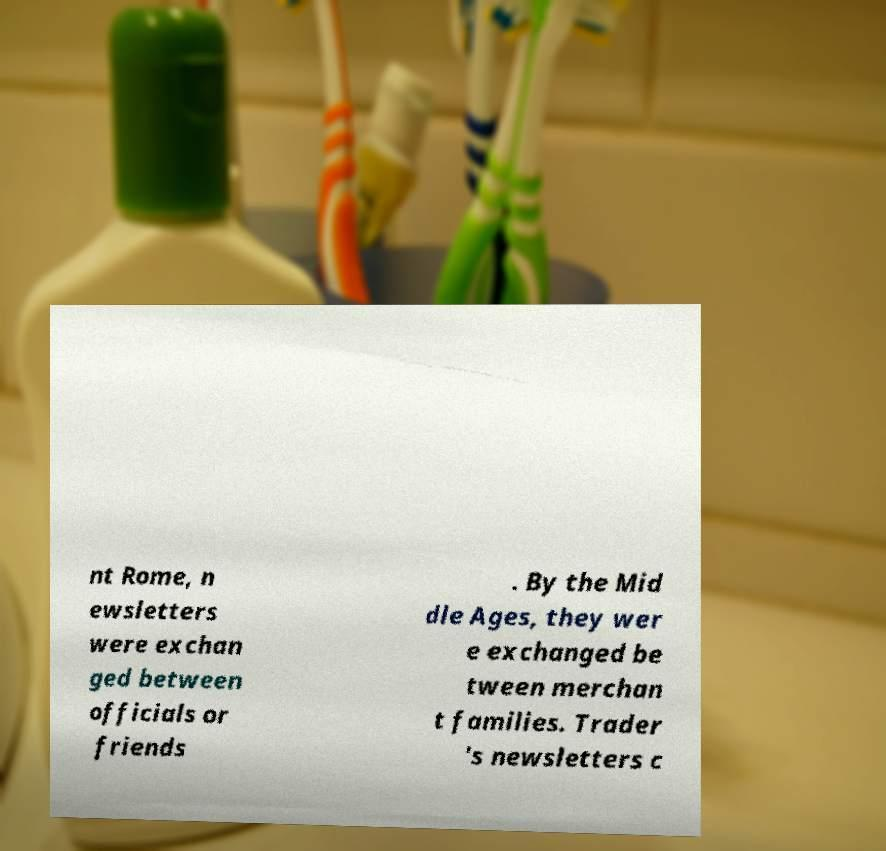What messages or text are displayed in this image? I need them in a readable, typed format. nt Rome, n ewsletters were exchan ged between officials or friends . By the Mid dle Ages, they wer e exchanged be tween merchan t families. Trader 's newsletters c 